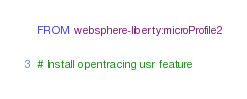Convert code to text. <code><loc_0><loc_0><loc_500><loc_500><_Dockerfile_>FROM websphere-liberty:microProfile2

# Install opentracing usr feature</code> 